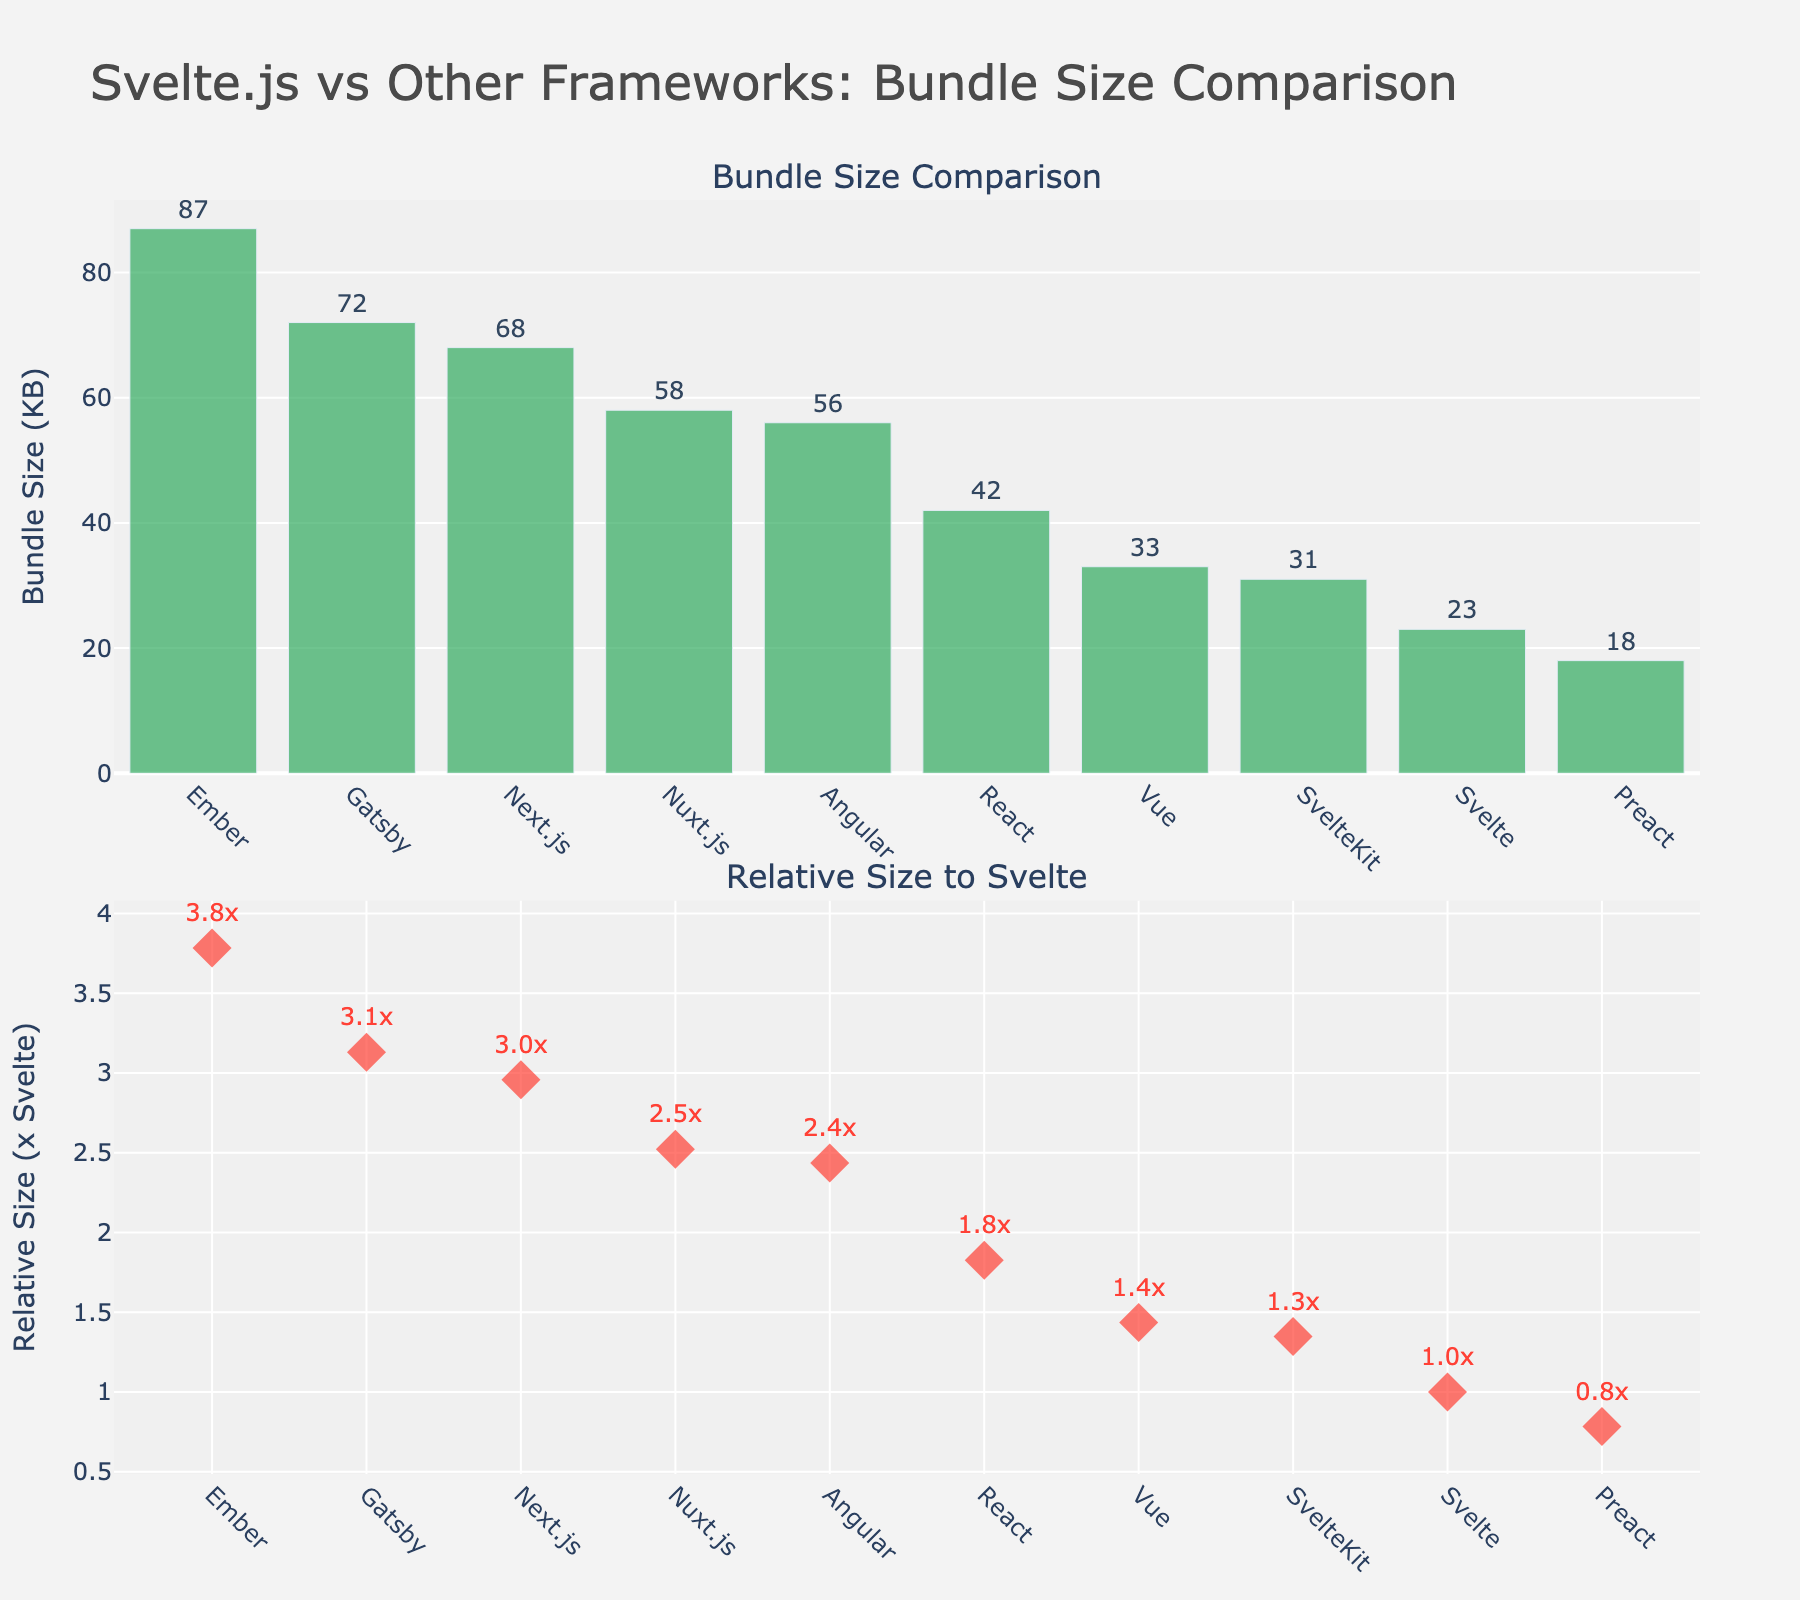What's the framework with the smallest bundle size? To find the framework with the smallest bundle size, look at the first subplot showing the bundle sizes of various frameworks in a bar chart. The smallest bundle size is represented by the shortest bar.
Answer: Preact What is the bundle size of Svelte? Directly look at the bar labeled 'Svelte' in the first subplot. The number labeled on top of the bar indicates its bundle size.
Answer: 23 KB Which framework has the largest bundle size? Observing the first subplot, identify the framework represented by the tallest bar, which indicates the largest bundle size.
Answer: Ember What's the bundle size difference between React and Angular? Refer to the first subplot. Find the bars for 'React' and 'Angular' and note their bundle sizes (42 KB for React and 56 KB for Angular). Compute the difference by subtracting the smaller bundle size from the larger one: \(56 - 42 = 14\) KB
Answer: 14 KB Which framework is slightly larger in bundle size, Vue or SvelteKit? In the first subplot, look at the bars for 'Vue' and 'SvelteKit'. Compare their bundle sizes. 'Vue' has a size of 33 KB and 'SvelteKit' has 31 KB. Therefore, Vue is slightly larger than SvelteKit.
Answer: Vue How many frameworks have a bundle size larger than 50 KB? In the first subplot, count the number of bars that extend beyond the 50 KB mark on the y-axis. These include Angular, Ember, Next.js, Nuxt.js, and Gatsby.
Answer: 5 What is Next.js's relative bundle size compared to Svelte? Refer to the second subplot that shows relative sizes compared to Svelte. Locate the marker for 'Next.js' and note the numerical value displayed.
Answer: 2.96x Which framework has a relative size closest to 1x Svelte? In the second subplot, locate the marker that is nearest to 1x. Compare the values and find which framework is closest to this mark.
Answer: SvelteKit What's the average bundle size of all frameworks? Sum up all the bundle sizes (23 + 42 + 33 + 56 + 18 + 87 + 68 + 58 + 31 + 72) and divide by the total number of frameworks (10). The sum is 488 KB. The average bundle size is \( \frac{488}{10} = 48.8 \) KB.
Answer: 48.8 KB Which framework is more than twice the size of Svelte? Examine the second subplot for markers above the 2x line. These frameworks have relative sizes more than twice that of Svelte. Identify 'Ember', 'Gatsby', 'Next.js', and 'Nuxt.js'.
Answer: Ember, Gatsby, Next.js, Nuxt.js 